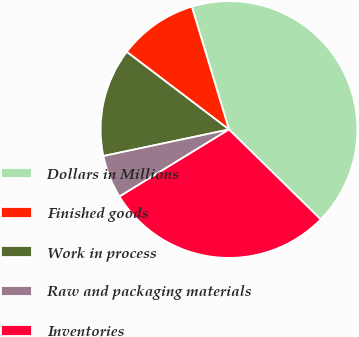Convert chart. <chart><loc_0><loc_0><loc_500><loc_500><pie_chart><fcel>Dollars in Millions<fcel>Finished goods<fcel>Work in process<fcel>Raw and packaging materials<fcel>Inventories<nl><fcel>42.02%<fcel>9.99%<fcel>13.65%<fcel>5.43%<fcel>28.92%<nl></chart> 